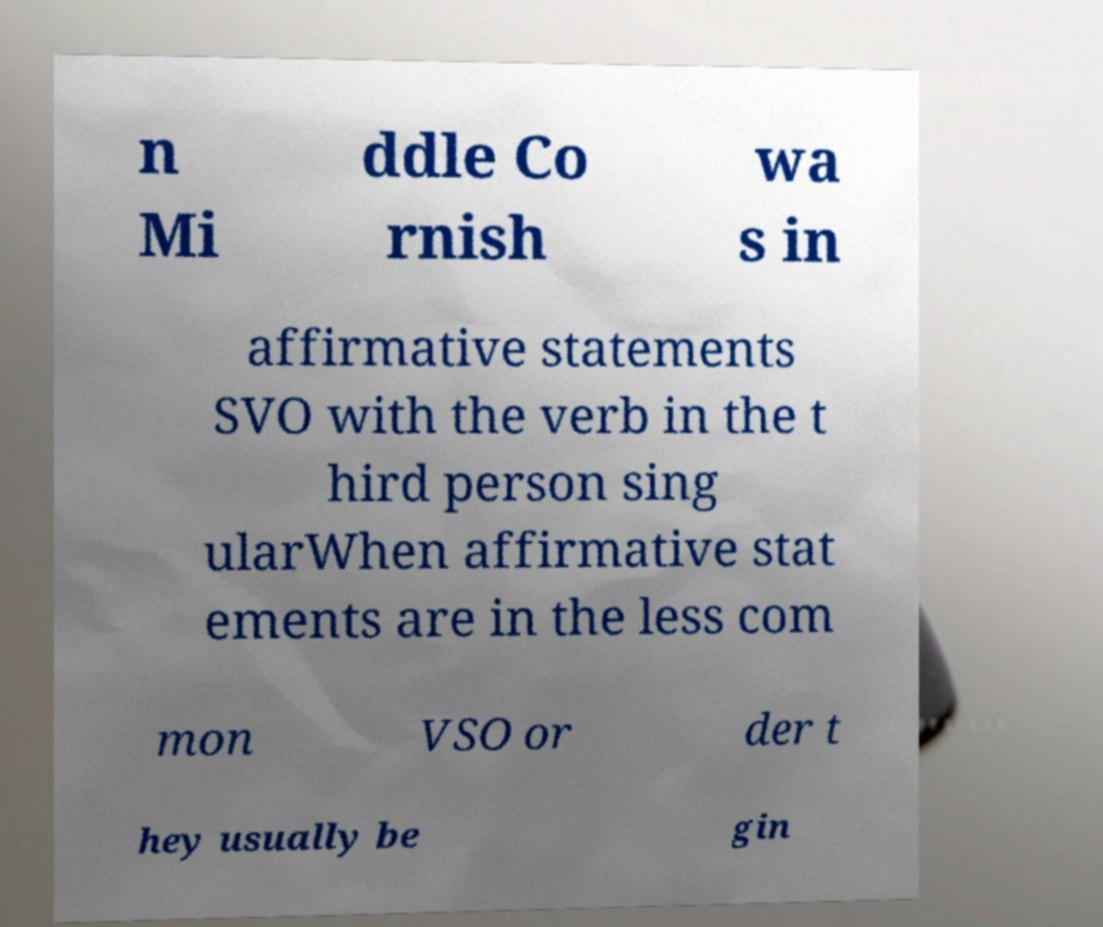There's text embedded in this image that I need extracted. Can you transcribe it verbatim? n Mi ddle Co rnish wa s in affirmative statements SVO with the verb in the t hird person sing ularWhen affirmative stat ements are in the less com mon VSO or der t hey usually be gin 